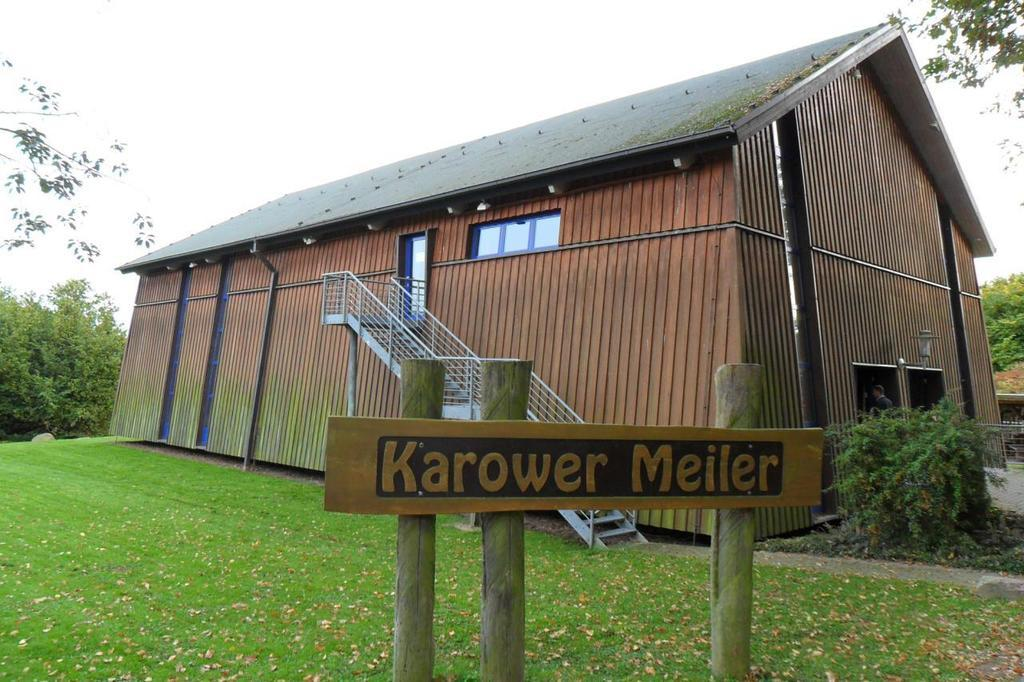What type of structure is present in the image? There is a shed in the image. What can be seen attached to the shed? There are staircase holders in the image. What is the purpose of the staircase holders? The staircase holders are used to support stairs. What is the main feature of the stairs in the image? There are stairs in the image. What is the board with poles used for in the image? The board with poles is likely used as a support structure for the stairs. What type of vegetation is present in the image? There are plants in the image. Who is present in the image? There is a person in the image. What can be seen in the background of the image? There are trees and the sky visible in the background of the image. What type of joke is the person telling in the image? There is no indication in the image that the person is telling a joke, so it cannot be determined from the picture. 